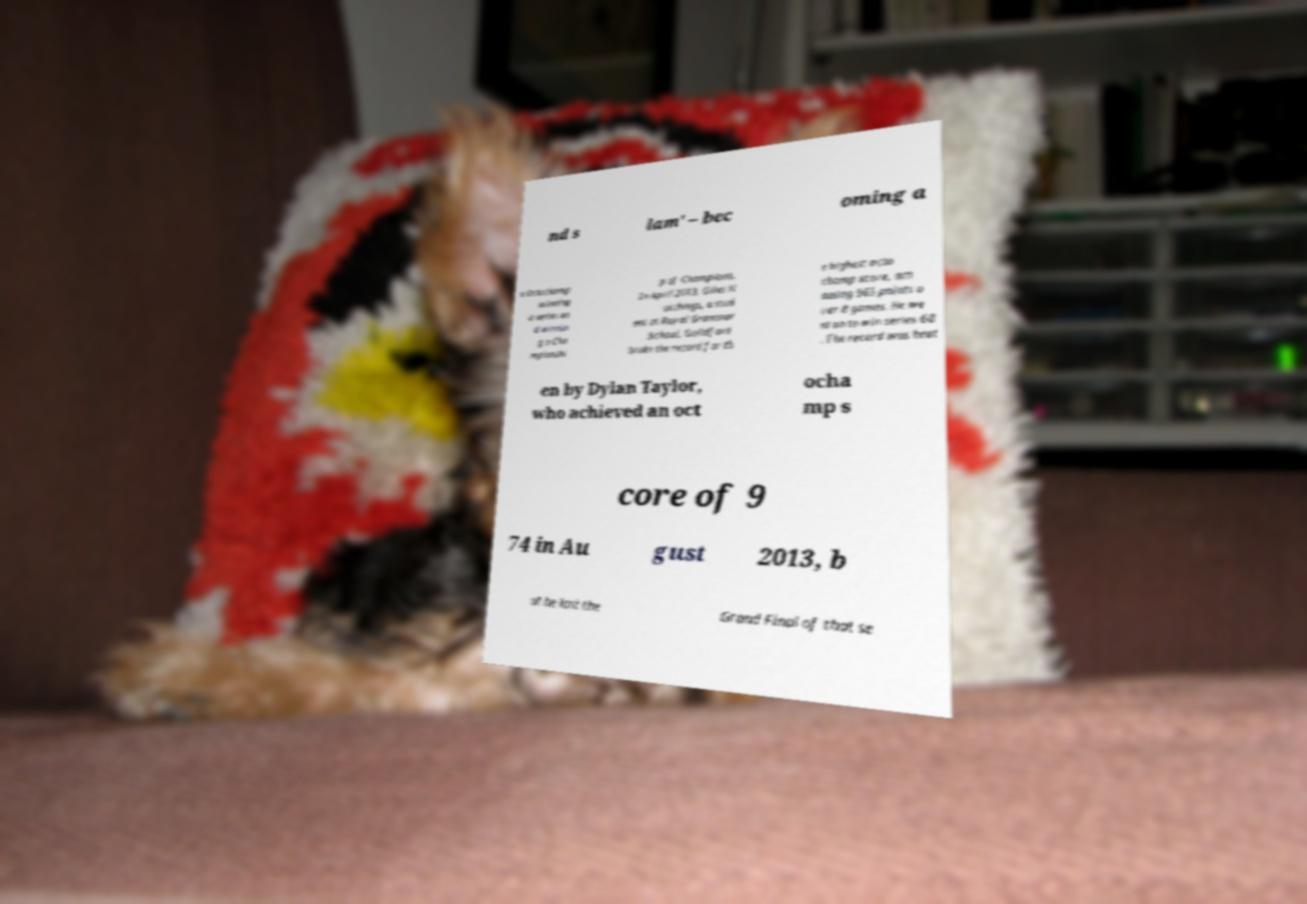Can you read and provide the text displayed in the image?This photo seems to have some interesting text. Can you extract and type it out for me? nd s lam' – bec oming a n Octochamp winning a series an d winnin g a Cha mpionshi p of Champions. In April 2013, Giles H utchings, a stud ent at Royal Grammar School, Guildford broke the record for th e highest octo champ score, am assing 965 points o ver 8 games. He we nt on to win series 68 . The record was beat en by Dylan Taylor, who achieved an oct ocha mp s core of 9 74 in Au gust 2013, b ut he lost the Grand Final of that se 